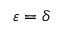Convert formula to latex. <formula><loc_0><loc_0><loc_500><loc_500>\varepsilon = \delta</formula> 